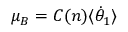Convert formula to latex. <formula><loc_0><loc_0><loc_500><loc_500>\mu _ { B } = C ( n ) \langle { \dot { \theta } } _ { 1 } \rangle</formula> 